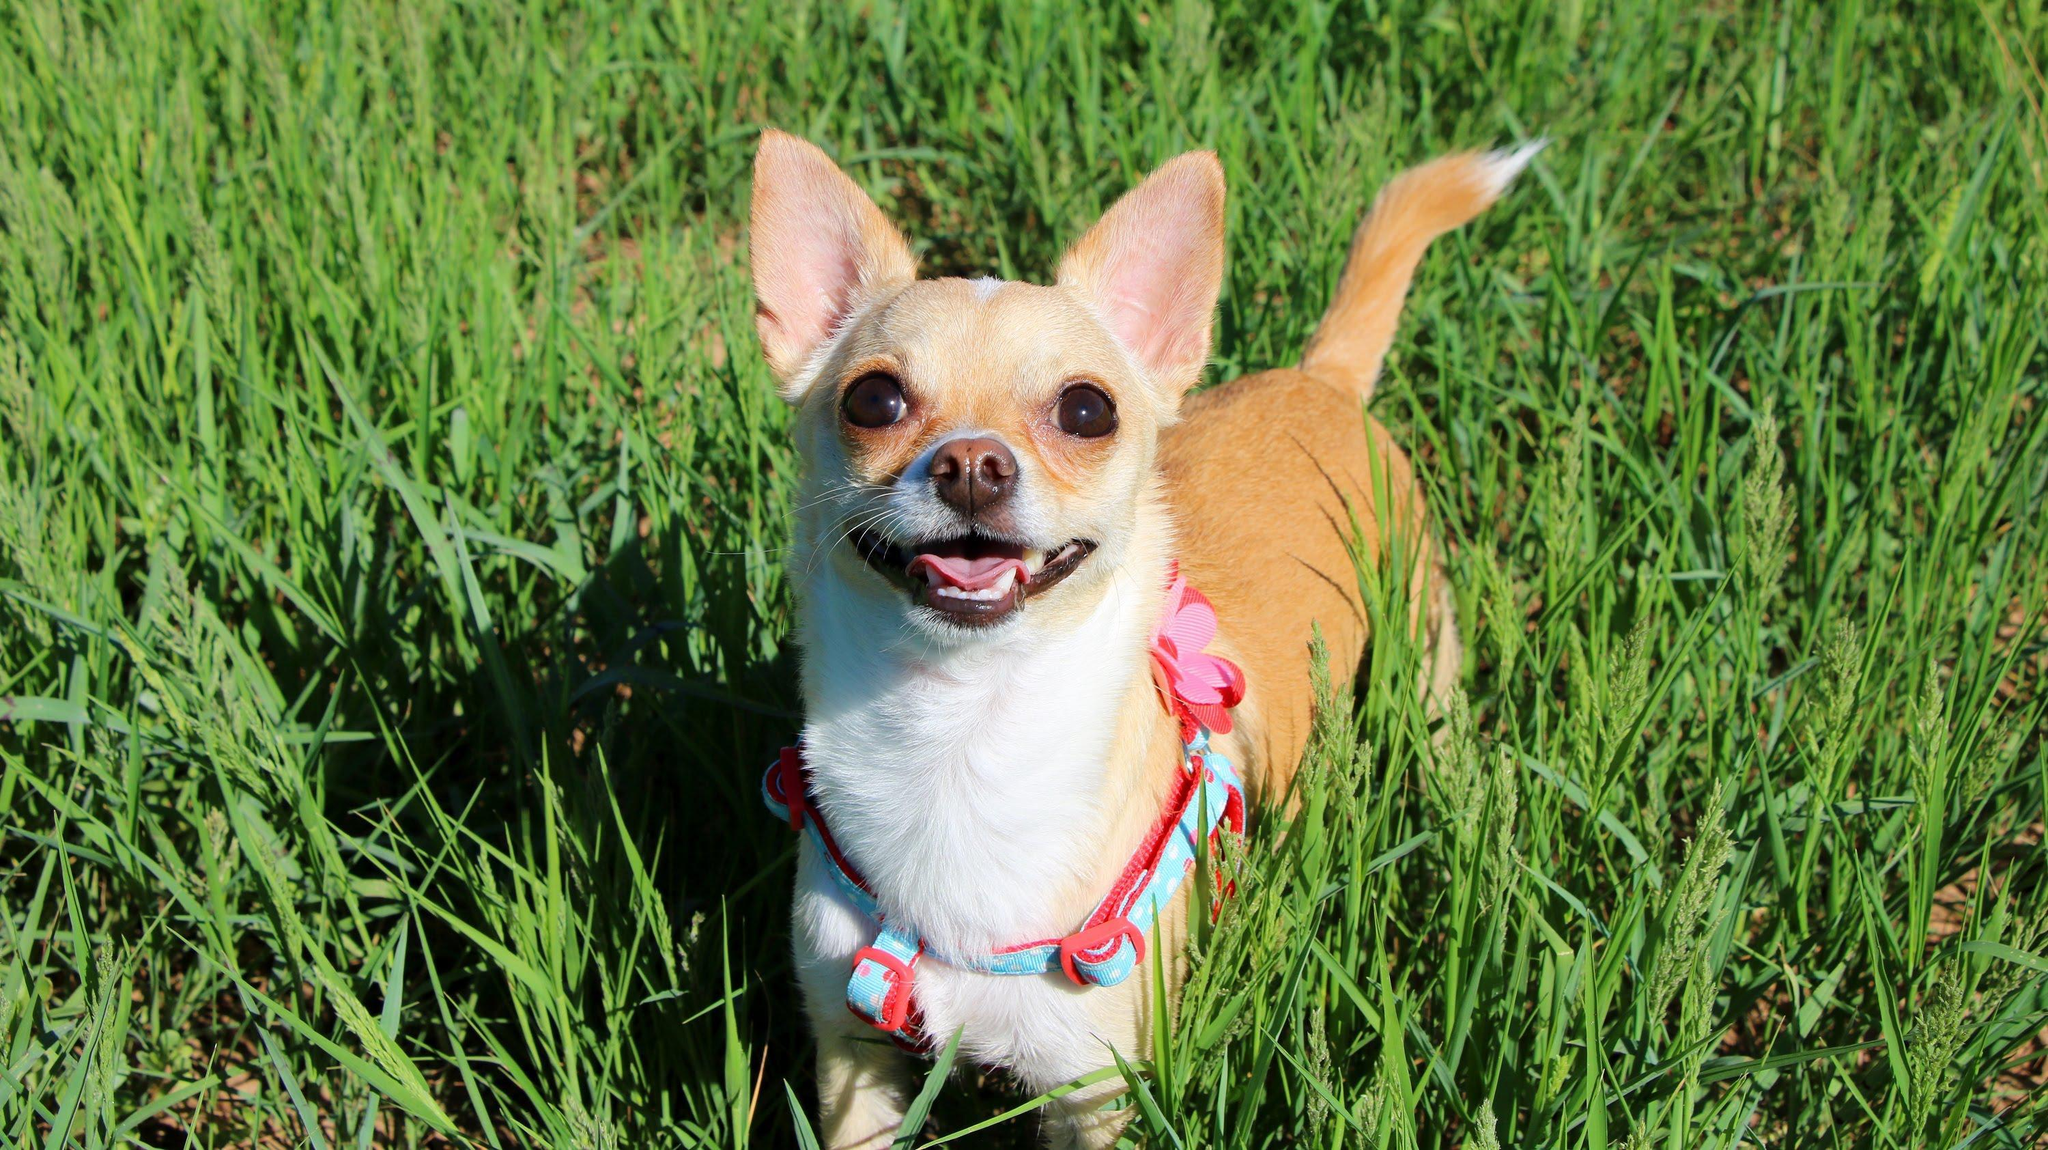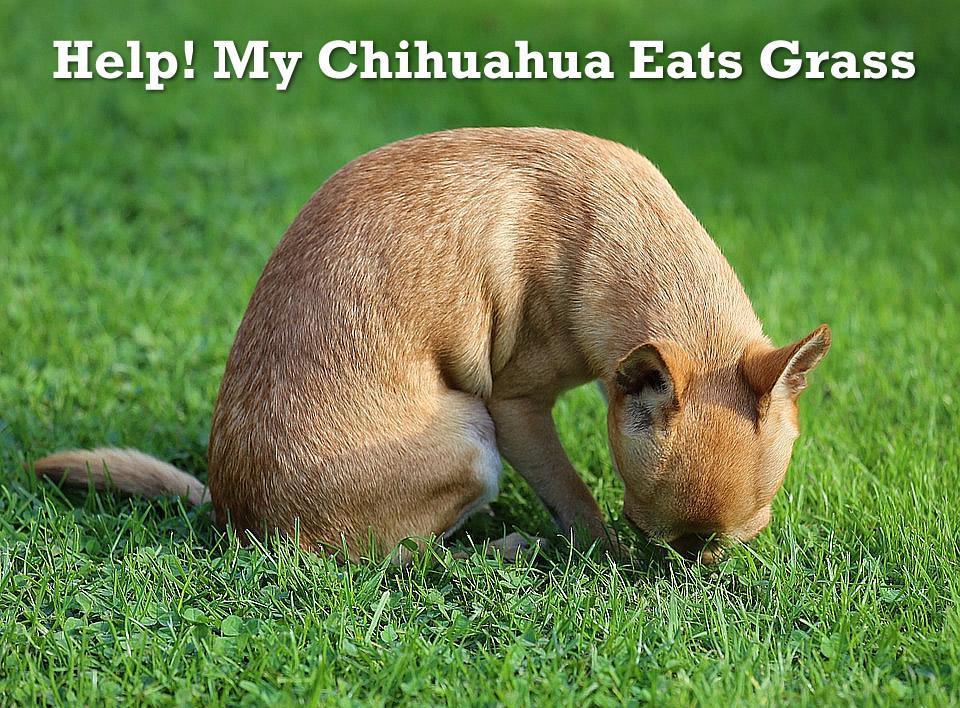The first image is the image on the left, the second image is the image on the right. For the images shown, is this caption "All chihuahuas are shown posed on green grass, and one chihuahua has its head pointed downward toward something green." true? Answer yes or no. Yes. 